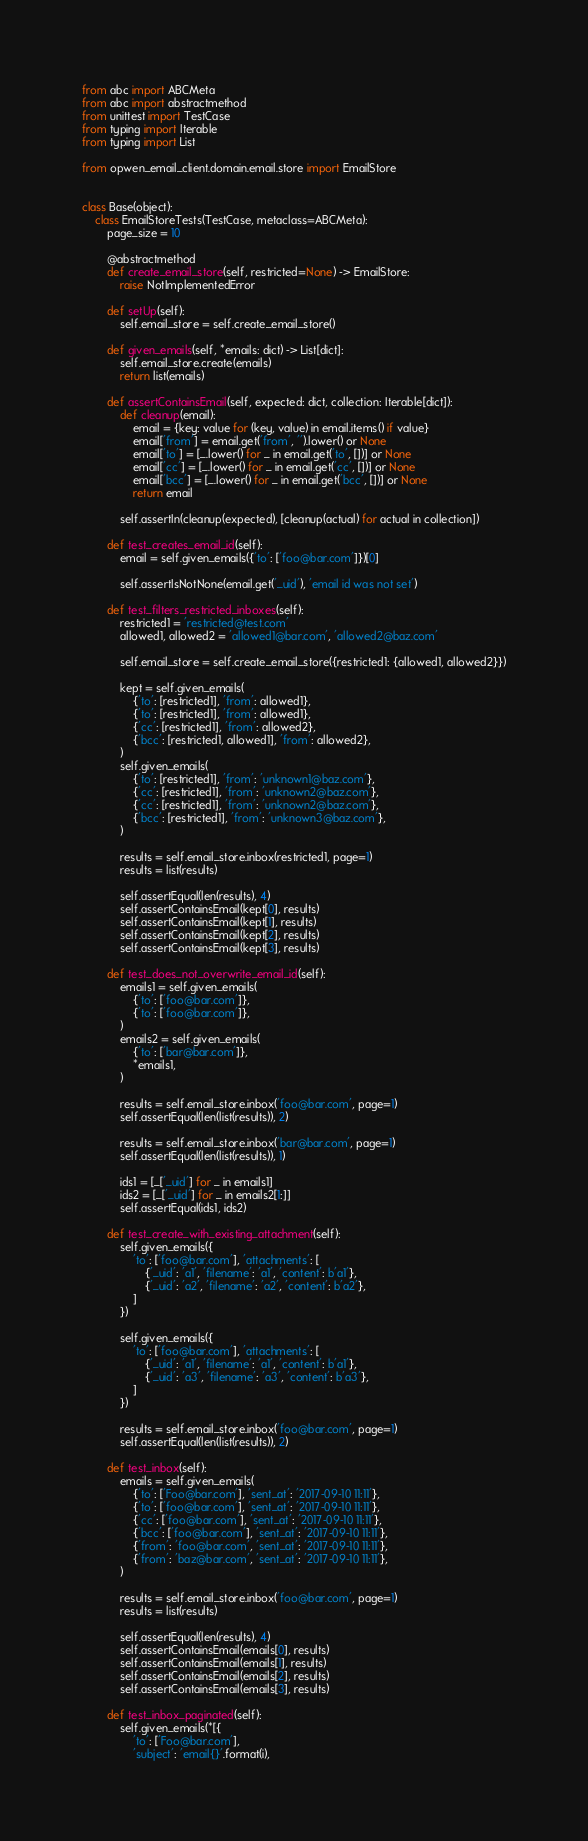Convert code to text. <code><loc_0><loc_0><loc_500><loc_500><_Python_>from abc import ABCMeta
from abc import abstractmethod
from unittest import TestCase
from typing import Iterable
from typing import List

from opwen_email_client.domain.email.store import EmailStore


class Base(object):
    class EmailStoreTests(TestCase, metaclass=ABCMeta):
        page_size = 10

        @abstractmethod
        def create_email_store(self, restricted=None) -> EmailStore:
            raise NotImplementedError

        def setUp(self):
            self.email_store = self.create_email_store()

        def given_emails(self, *emails: dict) -> List[dict]:
            self.email_store.create(emails)
            return list(emails)

        def assertContainsEmail(self, expected: dict, collection: Iterable[dict]):
            def cleanup(email):
                email = {key: value for (key, value) in email.items() if value}
                email['from'] = email.get('from', '').lower() or None
                email['to'] = [_.lower() for _ in email.get('to', [])] or None
                email['cc'] = [_.lower() for _ in email.get('cc', [])] or None
                email['bcc'] = [_.lower() for _ in email.get('bcc', [])] or None
                return email

            self.assertIn(cleanup(expected), [cleanup(actual) for actual in collection])

        def test_creates_email_id(self):
            email = self.given_emails({'to': ['foo@bar.com']})[0]

            self.assertIsNotNone(email.get('_uid'), 'email id was not set')

        def test_filters_restricted_inboxes(self):
            restricted1 = 'restricted@test.com'
            allowed1, allowed2 = 'allowed1@bar.com', 'allowed2@baz.com'

            self.email_store = self.create_email_store({restricted1: {allowed1, allowed2}})

            kept = self.given_emails(
                {'to': [restricted1], 'from': allowed1},
                {'to': [restricted1], 'from': allowed1},
                {'cc': [restricted1], 'from': allowed2},
                {'bcc': [restricted1, allowed1], 'from': allowed2},
            )
            self.given_emails(
                {'to': [restricted1], 'from': 'unknown1@baz.com'},
                {'cc': [restricted1], 'from': 'unknown2@baz.com'},
                {'cc': [restricted1], 'from': 'unknown2@baz.com'},
                {'bcc': [restricted1], 'from': 'unknown3@baz.com'},
            )

            results = self.email_store.inbox(restricted1, page=1)
            results = list(results)

            self.assertEqual(len(results), 4)
            self.assertContainsEmail(kept[0], results)
            self.assertContainsEmail(kept[1], results)
            self.assertContainsEmail(kept[2], results)
            self.assertContainsEmail(kept[3], results)

        def test_does_not_overwrite_email_id(self):
            emails1 = self.given_emails(
                {'to': ['foo@bar.com']},
                {'to': ['foo@bar.com']},
            )
            emails2 = self.given_emails(
                {'to': ['bar@bar.com']},
                *emails1,
            )

            results = self.email_store.inbox('foo@bar.com', page=1)
            self.assertEqual(len(list(results)), 2)

            results = self.email_store.inbox('bar@bar.com', page=1)
            self.assertEqual(len(list(results)), 1)

            ids1 = [_['_uid'] for _ in emails1]
            ids2 = [_['_uid'] for _ in emails2[1:]]
            self.assertEqual(ids1, ids2)

        def test_create_with_existing_attachment(self):
            self.given_emails({
                'to': ['foo@bar.com'], 'attachments': [
                    {'_uid': 'a1', 'filename': 'a1', 'content': b'a1'},
                    {'_uid': 'a2', 'filename': 'a2', 'content': b'a2'},
                ]
            })

            self.given_emails({
                'to': ['foo@bar.com'], 'attachments': [
                    {'_uid': 'a1', 'filename': 'a1', 'content': b'a1'},
                    {'_uid': 'a3', 'filename': 'a3', 'content': b'a3'},
                ]
            })

            results = self.email_store.inbox('foo@bar.com', page=1)
            self.assertEqual(len(list(results)), 2)

        def test_inbox(self):
            emails = self.given_emails(
                {'to': ['Foo@bar.com'], 'sent_at': '2017-09-10 11:11'},
                {'to': ['foo@bar.com'], 'sent_at': '2017-09-10 11:11'},
                {'cc': ['foo@bar.com'], 'sent_at': '2017-09-10 11:11'},
                {'bcc': ['foo@bar.com'], 'sent_at': '2017-09-10 11:11'},
                {'from': 'foo@bar.com', 'sent_at': '2017-09-10 11:11'},
                {'from': 'baz@bar.com', 'sent_at': '2017-09-10 11:11'},
            )

            results = self.email_store.inbox('foo@bar.com', page=1)
            results = list(results)

            self.assertEqual(len(results), 4)
            self.assertContainsEmail(emails[0], results)
            self.assertContainsEmail(emails[1], results)
            self.assertContainsEmail(emails[2], results)
            self.assertContainsEmail(emails[3], results)

        def test_inbox_paginated(self):
            self.given_emails(*[{
                'to': ['Foo@bar.com'],
                'subject': 'email{}'.format(i),</code> 